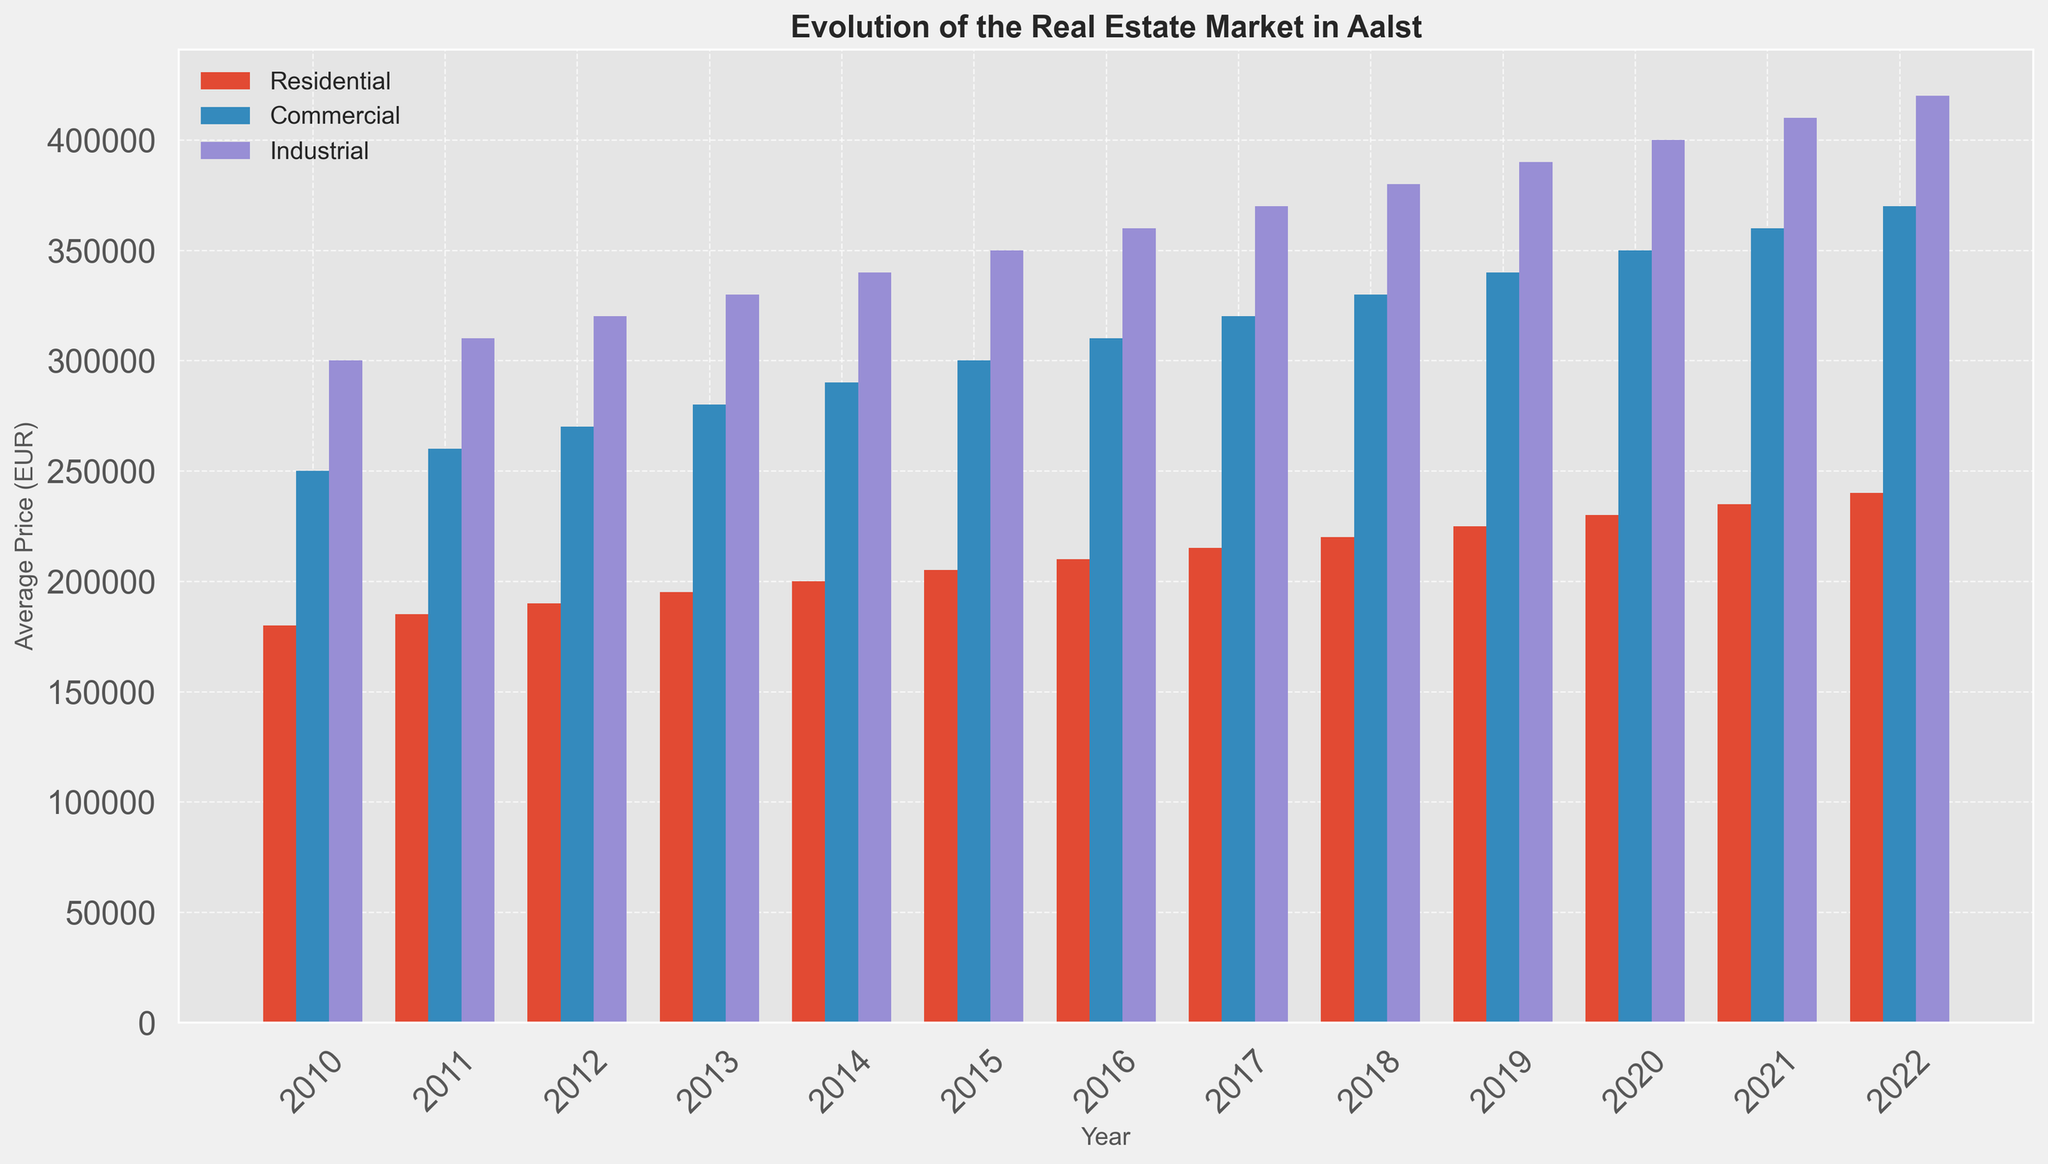Which year had the highest average price for residential properties? Look at the bars representing residential properties and observe which year has the tallest bar. The year 2022 has the highest average price for residential properties.
Answer: 2022 How much did the average price of industrial properties increase from 2010 to 2022? Check the heights of the industrial property bars for 2010 and 2022. The average price for industrial properties in 2010 is 300,000 EUR and in 2022 it’s 420,000 EUR. The difference is 120,000 EUR.
Answer: 120,000 EUR Which property type showed the greatest absolute increase in average price from 2010 to 2022? Compare the increases in heights of the bars for each property type from 2010 to 2022. Residential increased by 60,000 EUR, Commercial by 120,000 EUR, and Industrial by 120,000 EUR. So, both Commercial and Industrial showed the greatest absolute increase.
Answer: Commercial and Industrial In which year did commercial properties have their average price surpass 300,000 EUR for the first time? Identify the commercial property bars and check in which year the height of the bar first exceeds 300,000 EUR. It surpasses 300,000 EUR in 2015.
Answer: 2015 How does the growth in average price for commercial properties between 2010 and 2020 compare to the growth for residential properties in the same period? Calculate the difference in average price for both property types from 2010 to 2020. For commercial: 350,000 EUR - 250,000 EUR = 100,000 EUR. For residential: 230,000 EUR - 180,000 EUR = 50,000 EUR. So, commercial properties had a greater increase.
Answer: Commercial properties had greater growth Which year had the smallest average price difference between commercial and industrial properties? Calculate the difference in heights between commercial and industrial property bars for each year, then identify the year with the smallest difference. The year 2010 has the smallest difference of 50,000 EUR (300,000 - 250,000=50,000).
Answer: 2010 Did residential properties’ average price in 2015 exceed the commercial properties’ average price in 2011? Compare the heights of the residential property bar in 2015 and the commercial property bar in 2011. Residential in 2015 is 205,000 EUR and commercial in 2011 is 260,000 EUR, so residential in 2015 did not exceed commercial in 2011.
Answer: No Which property type has the most consistent growth in its average price over the years? Analyze the trends of the heights of the bars for each property type from 2010 to 2022. Residential properties’ prices increase steadily without any large fluctuations, indicating consistent growth.
Answer: Residential properties What was the average price of all property types combined in 2012? Sum the average prices of all property types in 2012 and divide by 3. (190,000 + 270,000 + 320,000) EUR / 3 = 260,000 EUR.
Answer: 260,000 EUR Which property type saw the highest average price in any single year between 2010 and 2022? Identify the tallest bar among all property types for any single year. Industrial properties reached the highest average price of 420,000 EUR in 2022.
Answer: Industrial properties 